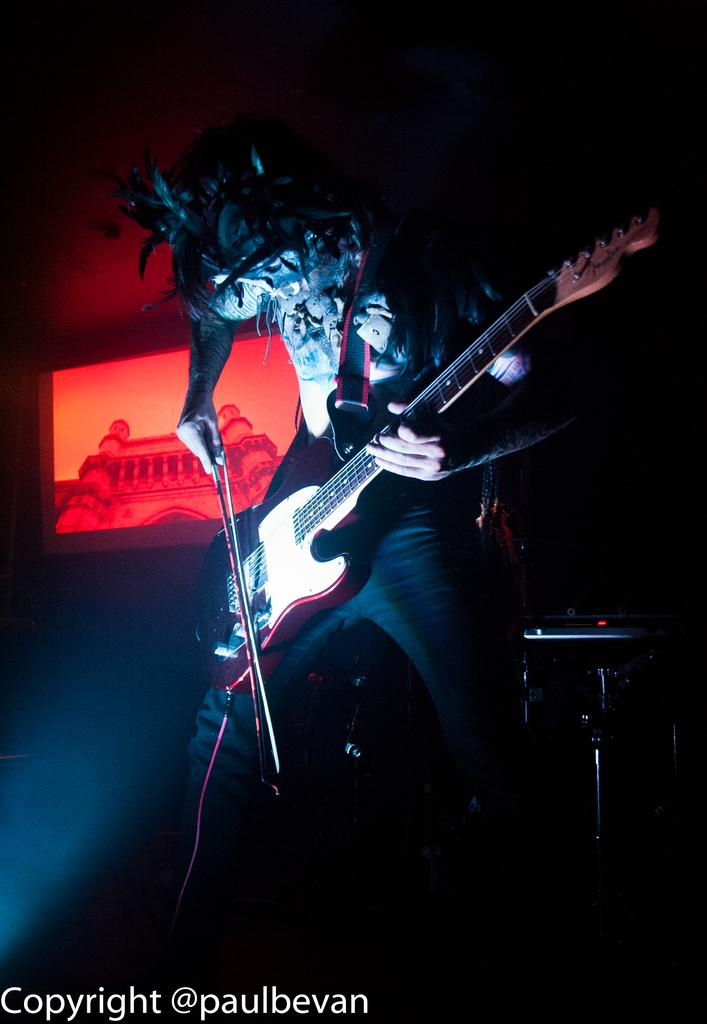What is the main activity being performed in the image? There is a person playing the guitar in the image. Can you describe the colorful image on the left side of the image? Unfortunately, the facts provided do not give any information about the colorful image on the left side. However, we can say that there is a red color image on the left side of the image. How many basketballs are visible in the image? There are no basketballs present in the image. What type of jeans is the person wearing while playing the guitar? The facts provided do not give any information about the person's clothing, so we cannot determine if they are wearing jeans or any other type of clothing. 